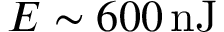<formula> <loc_0><loc_0><loc_500><loc_500>E \sim 6 0 0 \, n J</formula> 